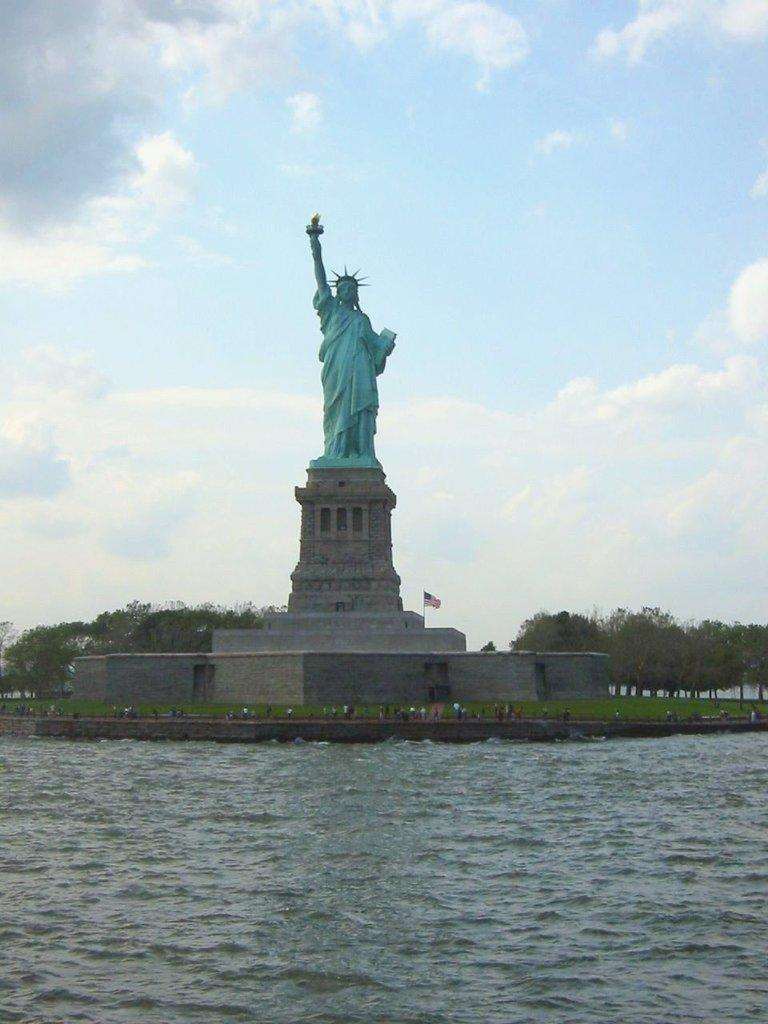What is the main subject in the middle of the image? There is a statue of liberty in the middle of the image. What is present at the bottom of the image? There is water at the bottom of the image. What can be seen in the background of the image? There are trees in the background of the image. What is visible at the top of the image? The sky is visible at the top of the image. Can you see any goldfish swimming in the water at the bottom of the image? There are no goldfish present in the image; it features a statue of liberty, water, trees, and the sky. 